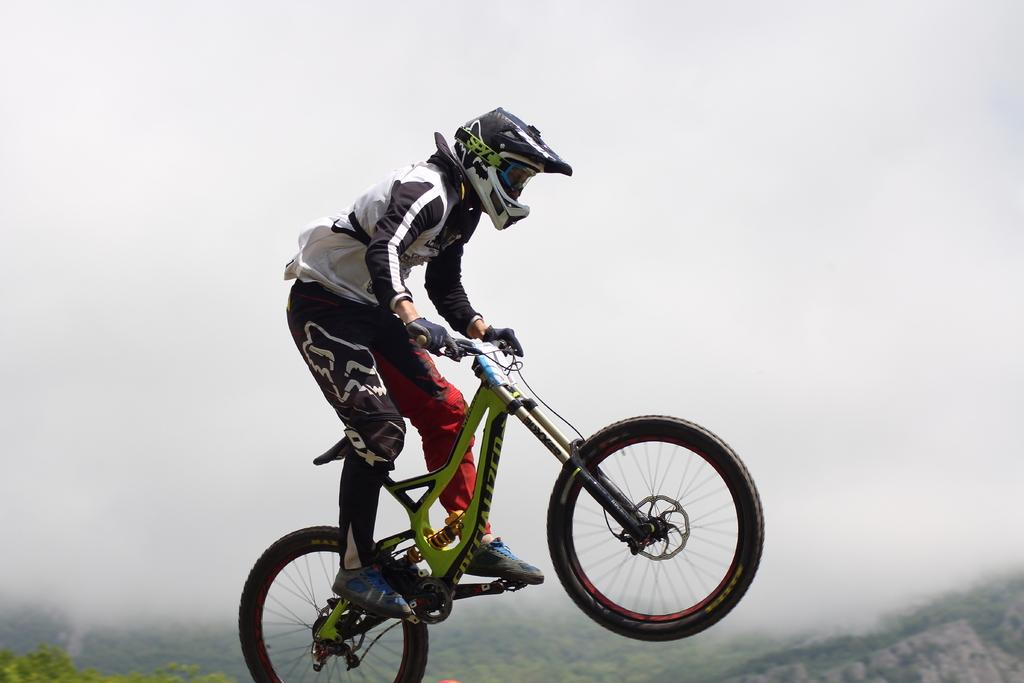Who is the main subject in the image? There is a man in the image. What is the man doing in the image? The man is jumping with a bicycle in the air. What can be seen in the background of the image? There are trees and the sky visible in the background of the image. How many ears of corn can be seen in the image? There is no corn present in the image. What type of club is the man holding in the image? The man is not holding any club in the image; he is jumping with a bicycle. 